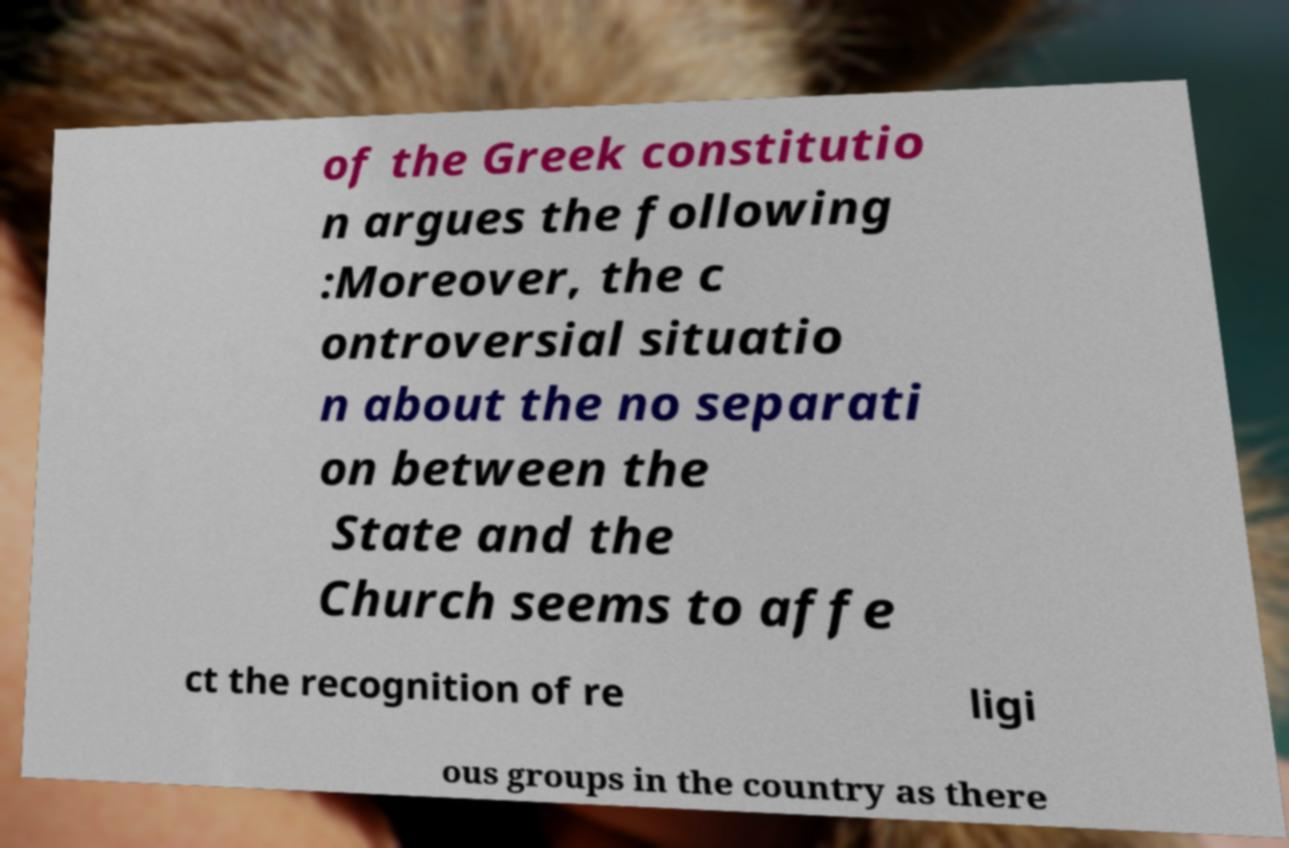There's text embedded in this image that I need extracted. Can you transcribe it verbatim? of the Greek constitutio n argues the following :Moreover, the c ontroversial situatio n about the no separati on between the State and the Church seems to affe ct the recognition of re ligi ous groups in the country as there 